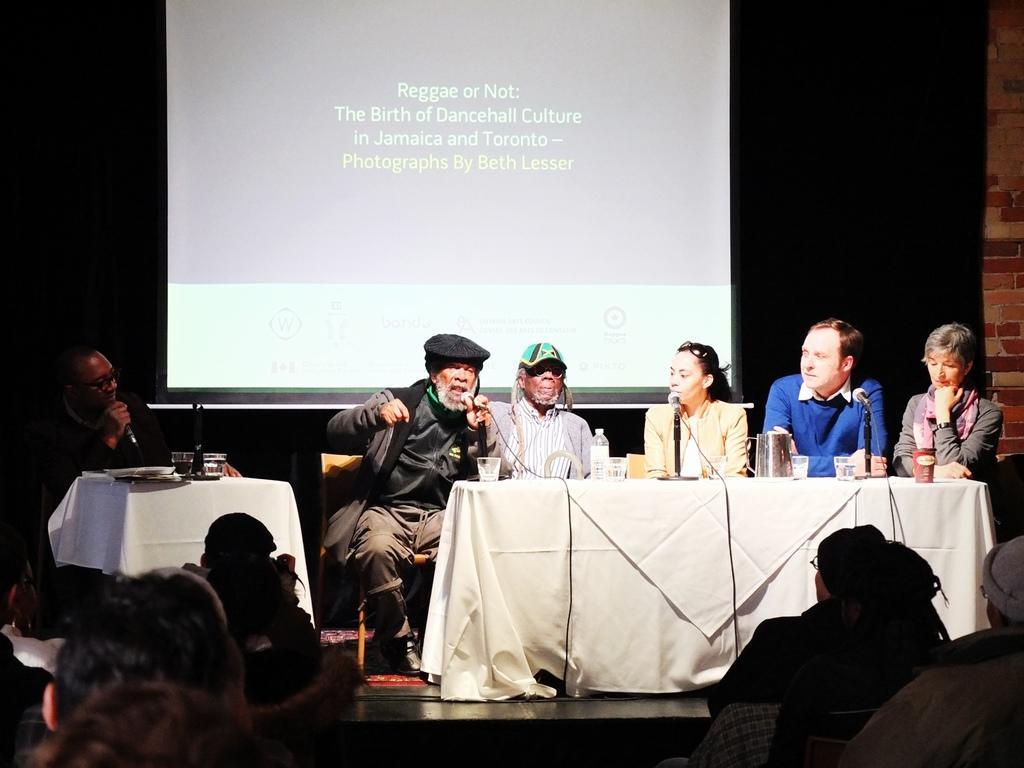Could you give a brief overview of what you see in this image? In the center of the image there are persons sitting at the table. On the table we can see cloth, glasses, bottles and mics. At the bottom of the image we can see persons. In the background we can see wall and screen. 